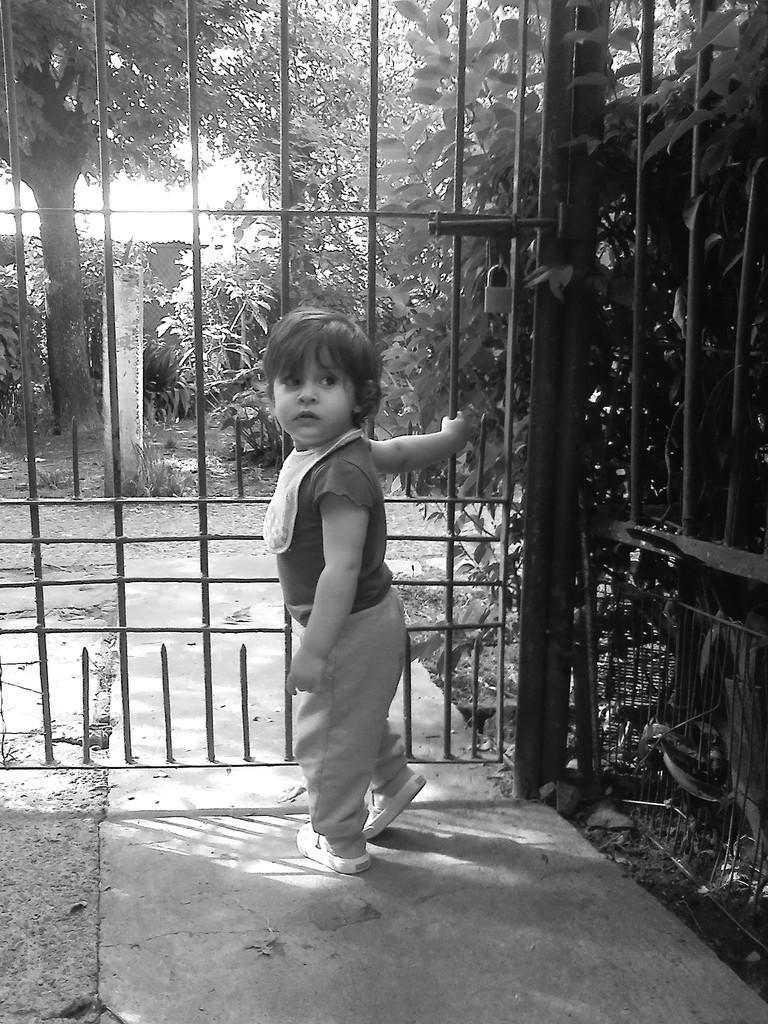In one or two sentences, can you explain what this image depicts? This is a black and white image. In the center of the image we can see a boy is standing. In the background of the image we can see trees, pole, door, lock, grills and some plants. At the bottom of the image there is a ground. 